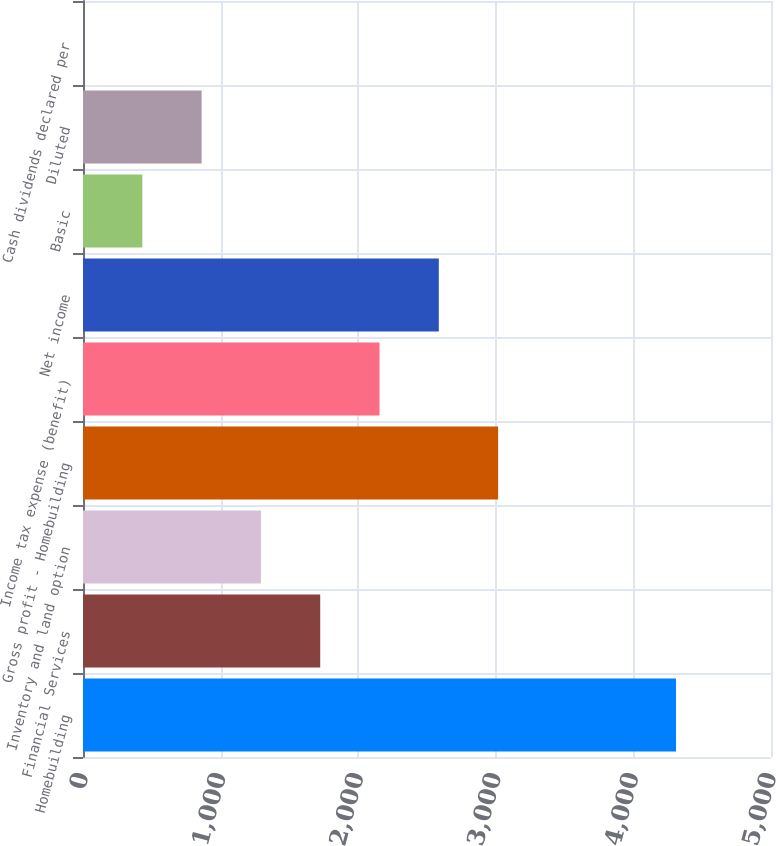Convert chart. <chart><loc_0><loc_0><loc_500><loc_500><bar_chart><fcel>Homebuilding<fcel>Financial Services<fcel>Inventory and land option<fcel>Gross profit - Homebuilding<fcel>Income tax expense (benefit)<fcel>Net income<fcel>Basic<fcel>Diluted<fcel>Cash dividends declared per<nl><fcel>4309.7<fcel>1723.99<fcel>1293.03<fcel>3016.86<fcel>2154.95<fcel>2585.9<fcel>431.11<fcel>862.07<fcel>0.15<nl></chart> 